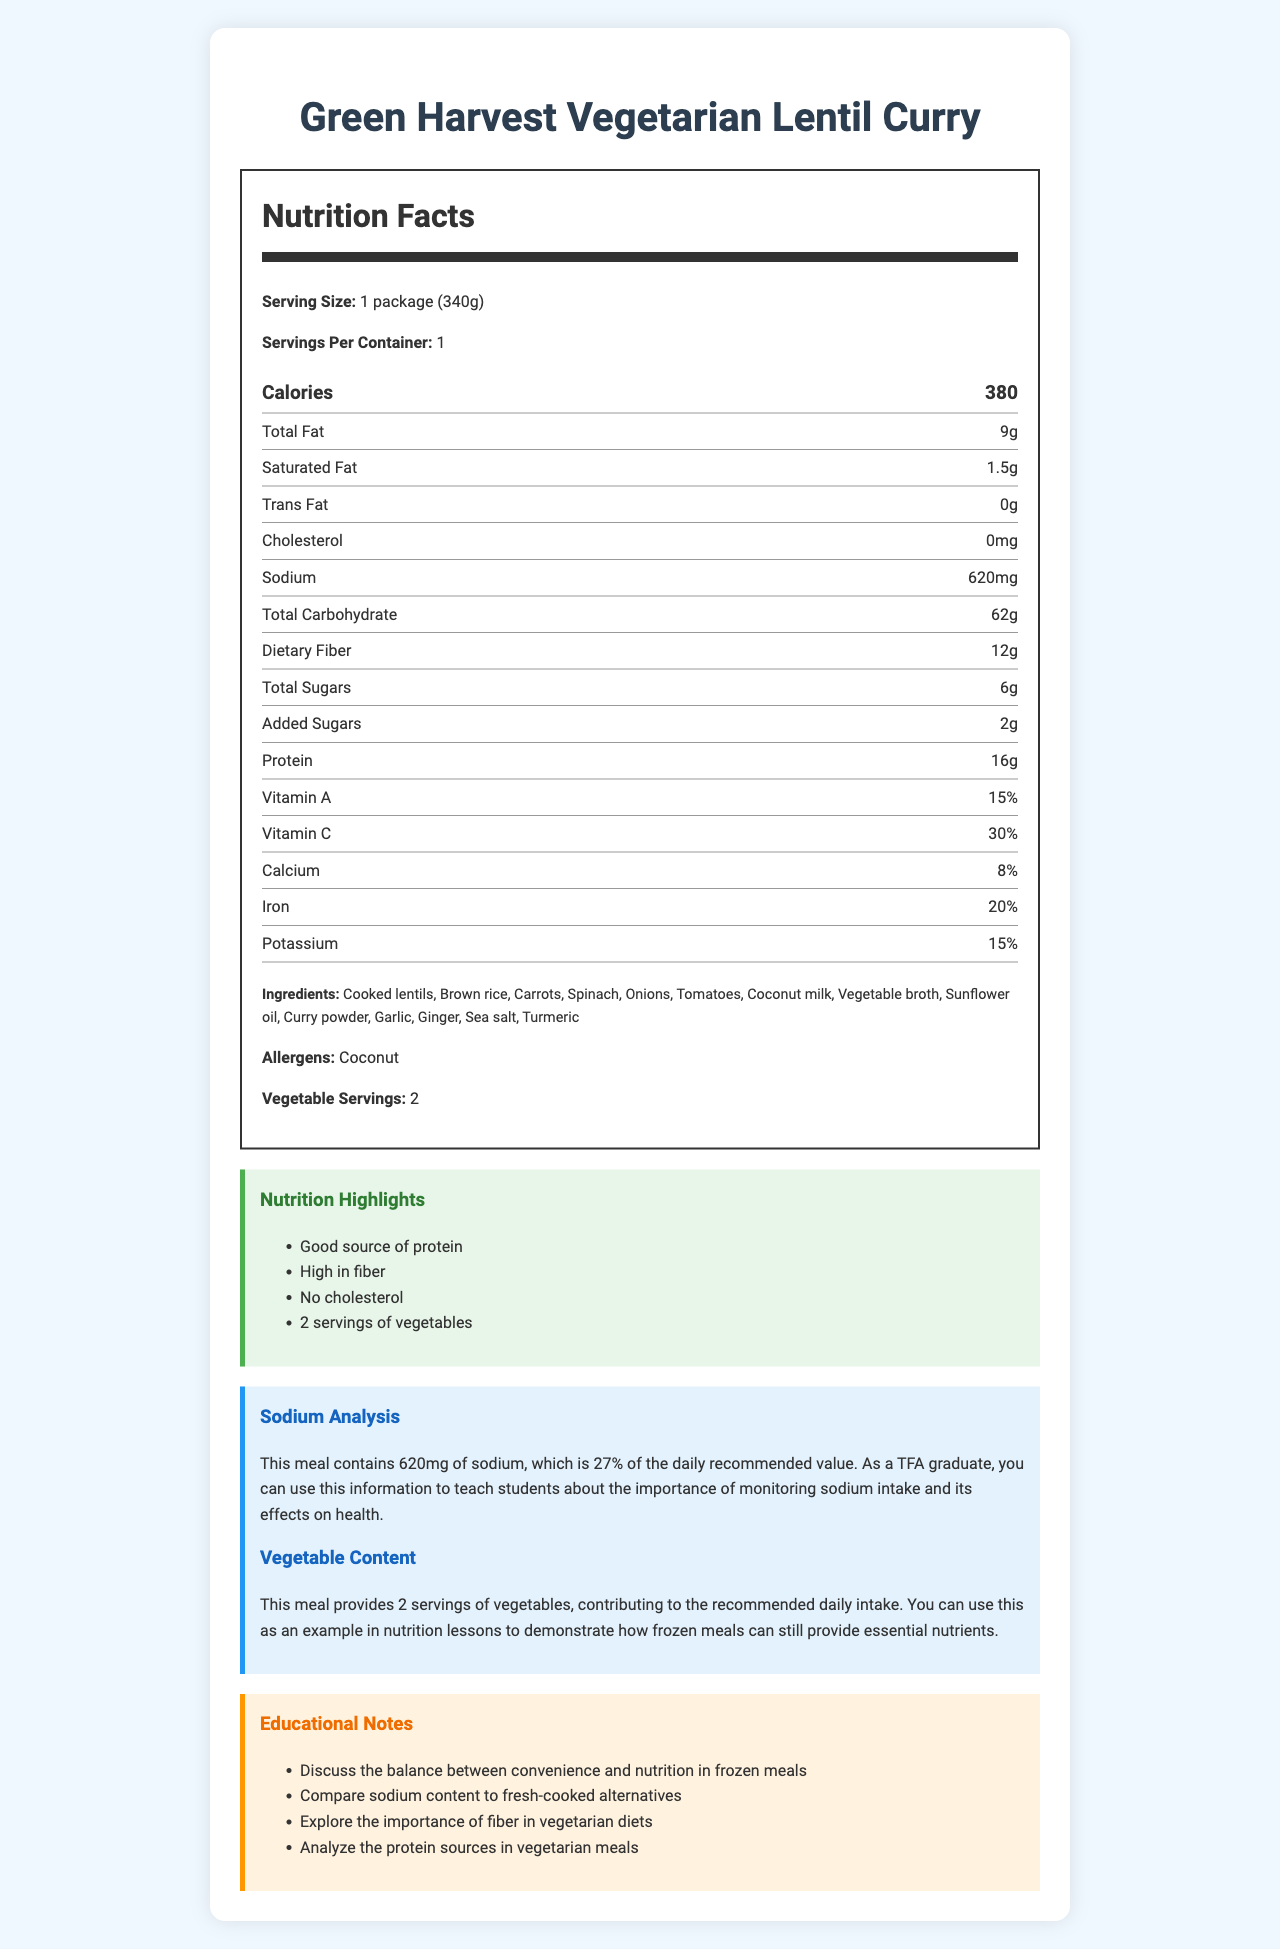How much sodium is in one serving of Green Harvest Vegetarian Lentil Curry? The nutrition label shows that the meal contains 620mg of sodium per serving.
Answer: 620mg How many servings of vegetables does this meal provide? The document states that the meal contains 2 servings of vegetables.
Answer: 2 servings What is the serving size for the Green Harvest Vegetarian Lentil Curry? The document specifies the serving size as 1 package or 340 grams.
Answer: 1 package (340g) What is the daily recommended value percentage for sodium in this meal? The sodium analysis section states that the meal contains 620mg of sodium, which is 27% of the daily recommended value.
Answer: 27% What are the highlights of the nutrition content in the Green Harvest Vegetarian Lentil Curry? The document includes these points under the "Nutrition Highlights" section.
Answer: Good source of protein, High in fiber, No cholesterol, 2 servings of vegetables Which of the following is an allergen present in this meal? A. Soy B. Dairy C. Coconut D. Gluten The ingredients section lists coconut as an allergen.
Answer: C. Coconut What percentage of the daily recommended value of iron does this meal provide? A. 8% B. 20% C. 15% D. 10% The nutrition facts section indicates that the meal provides 20% of the daily recommended value for iron.
Answer: B. 20% Which ingredient is NOT in the Green Harvest Vegetarian Lentil Curry? A. Lentils B. Spinach C. Chicken D. Turmeric The list of ingredients does not include chicken.
Answer: C. Chicken Is this meal free from cholesterol? The nutrition facts section shows that the meal contains 0mg of cholesterol.
Answer: Yes Summarize the main nutritional features of the Green Harvest Vegetarian Lentil Curry. A detailed description of the main features from the nutrition facts, highlights, and analysis sections of the document.
Answer: The Green Harvest Vegetarian Lentil Curry is a nutritious vegetarian meal with 380 calories per serving. It contains 620mg of sodium, which is 27% of the daily recommended value, and provides 2 servings of vegetables. It is a good source of protein and fiber, has no cholesterol, and includes vitamins and minerals such as Vitamin A, Vitamin C, Calcium, and Iron. How does the sodium content of this frozen meal compare with fresh-cooked alternatives? The document does not provide details or comparisons with fresh-cooked alternatives regarding sodium content.
Answer: Not enough information What is the total fat content of the meal? The nutrition facts section lists that the total fat content is 9 grams.
Answer: 9g 